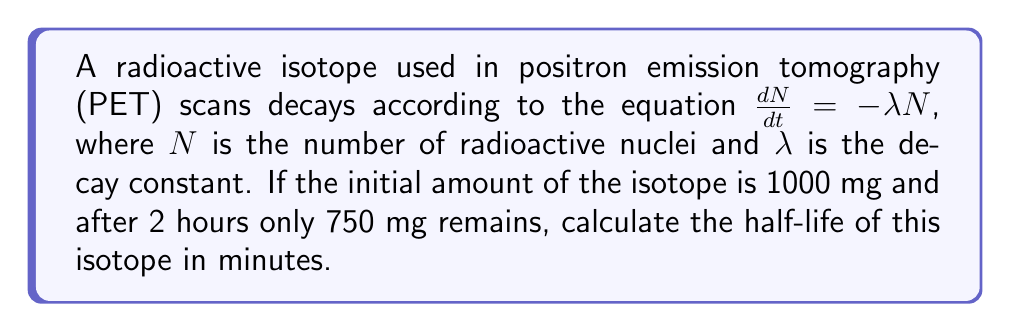Help me with this question. To solve this problem, we'll follow these steps:

1) The decay equation $\frac{dN}{dt} = -\lambda N$ has the solution:

   $N(t) = N_0e^{-\lambda t}$

   where $N_0$ is the initial amount and $t$ is time.

2) We're given that $N_0 = 1000$ mg and after 2 hours, $N(2) = 750$ mg. Let's substitute these into our equation:

   $750 = 1000e^{-2\lambda}$

3) Dividing both sides by 1000:

   $0.75 = e^{-2\lambda}$

4) Taking the natural log of both sides:

   $\ln(0.75) = -2\lambda$

5) Solving for $\lambda$:

   $\lambda = -\frac{\ln(0.75)}{2} \approx 0.1438$ per hour

6) The half-life $t_{1/2}$ is the time it takes for half of the substance to decay. It's related to $\lambda$ by:

   $t_{1/2} = \frac{\ln(2)}{\lambda}$

7) Substituting our value for $\lambda$:

   $t_{1/2} = \frac{\ln(2)}{0.1438} \approx 4.8194$ hours

8) Converting to minutes:

   $4.8194 \text{ hours} \times 60 \text{ minutes/hour} = 289.16$ minutes
Answer: The half-life of the radioactive isotope is approximately 289 minutes. 